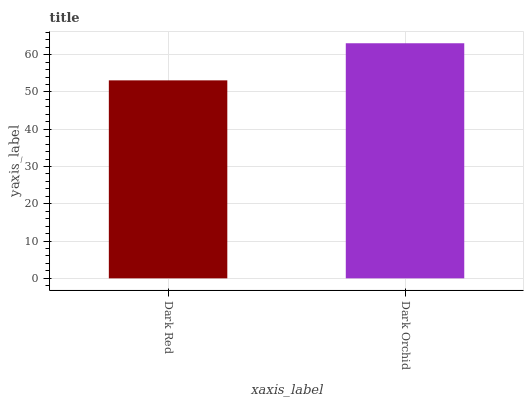Is Dark Red the minimum?
Answer yes or no. Yes. Is Dark Orchid the maximum?
Answer yes or no. Yes. Is Dark Orchid the minimum?
Answer yes or no. No. Is Dark Orchid greater than Dark Red?
Answer yes or no. Yes. Is Dark Red less than Dark Orchid?
Answer yes or no. Yes. Is Dark Red greater than Dark Orchid?
Answer yes or no. No. Is Dark Orchid less than Dark Red?
Answer yes or no. No. Is Dark Orchid the high median?
Answer yes or no. Yes. Is Dark Red the low median?
Answer yes or no. Yes. Is Dark Red the high median?
Answer yes or no. No. Is Dark Orchid the low median?
Answer yes or no. No. 